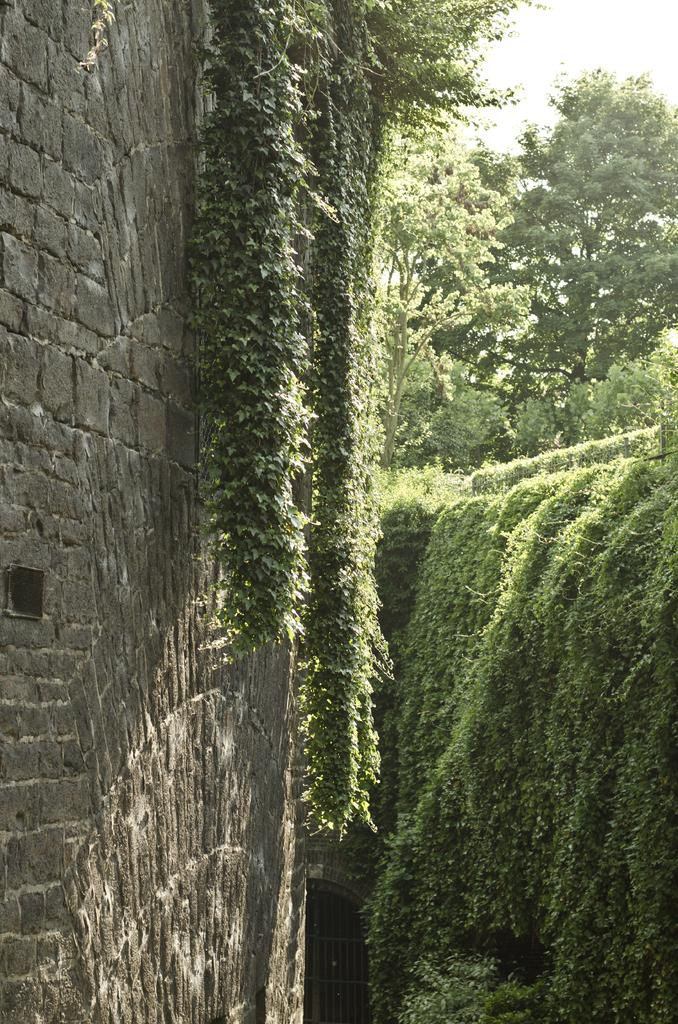What type of vegetation is present in the image? There are trees with branches and leaves in the image. Can you describe the trees further? The trees may be creepers, as they are not clearly visible. What else can be seen in the image besides the trees? There is a building wall and an iron gate at the bottom of the image. What news is being reported by the trees in the image? There are no trees reporting news in the image; they are simply trees with branches and leaves. 